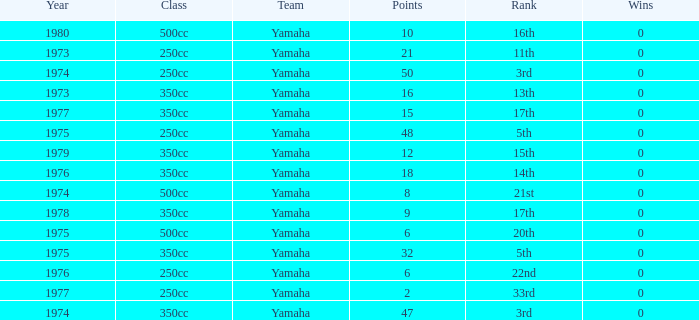Which Wins have a Class of 500cc, and a Year smaller than 1975? 0.0. 